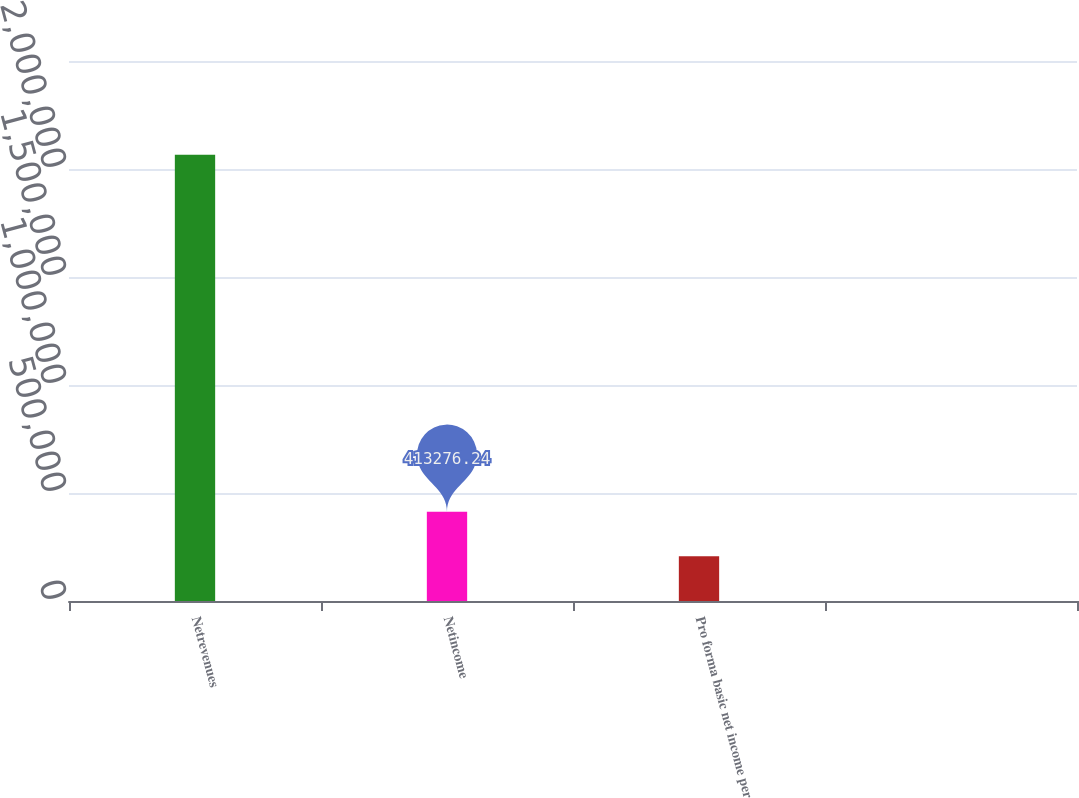<chart> <loc_0><loc_0><loc_500><loc_500><bar_chart><fcel>Netrevenues<fcel>Netincome<fcel>Pro forma basic net income per<fcel>Unnamed: 3<nl><fcel>2.06637e+06<fcel>413276<fcel>206639<fcel>2.56<nl></chart> 